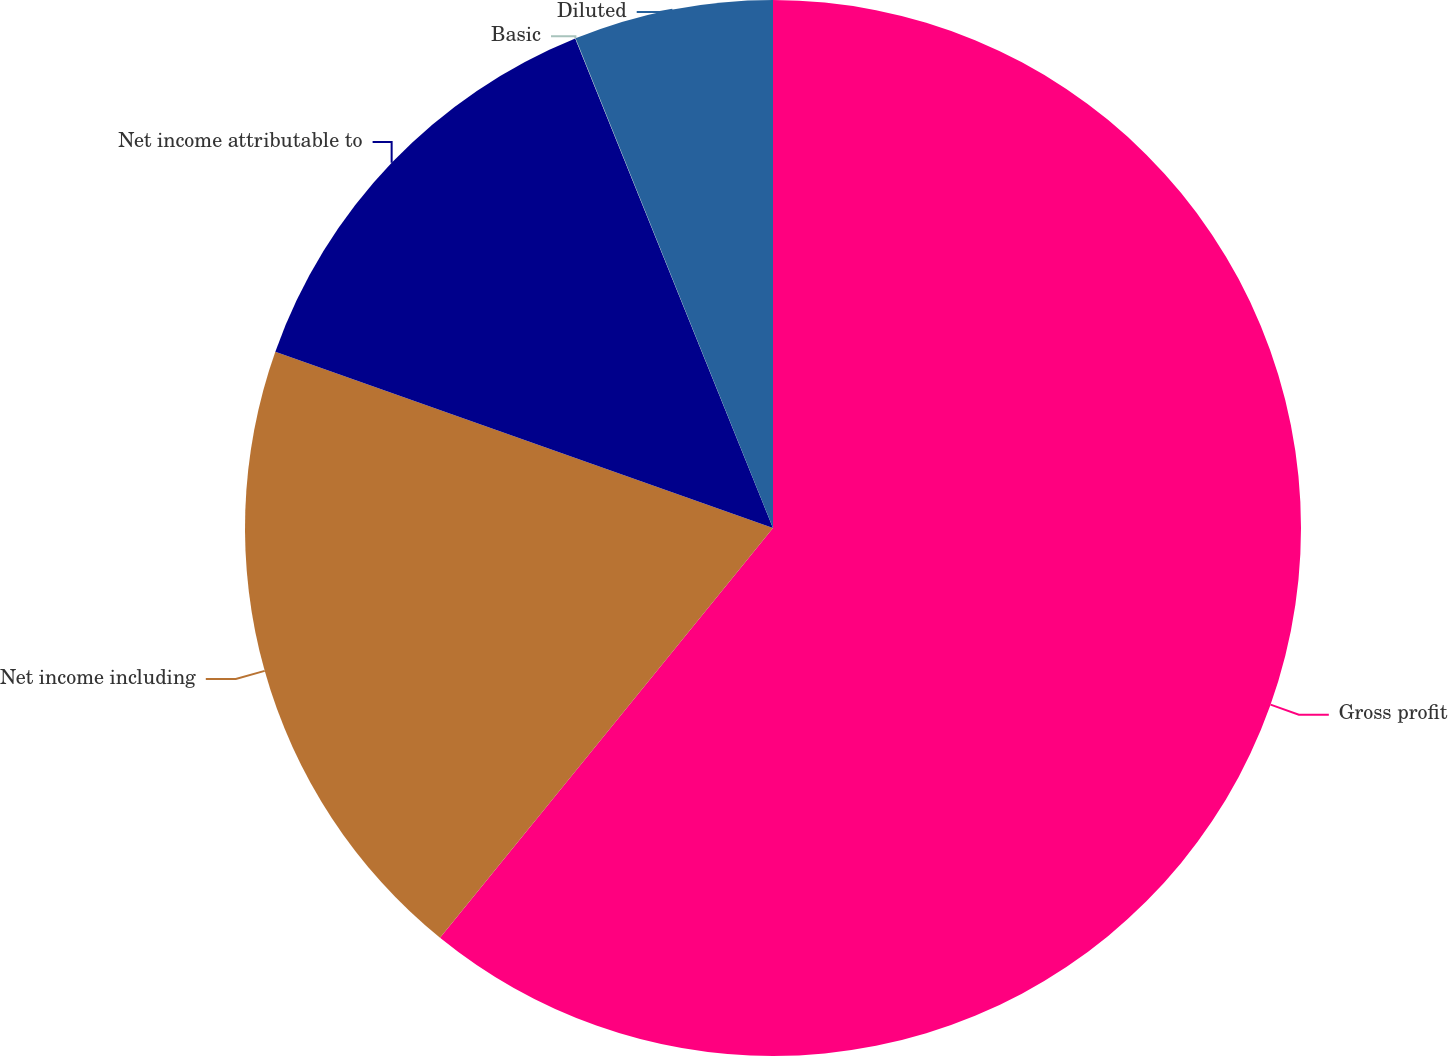Convert chart to OTSL. <chart><loc_0><loc_0><loc_500><loc_500><pie_chart><fcel>Gross profit<fcel>Net income including<fcel>Net income attributable to<fcel>Basic<fcel>Diluted<nl><fcel>60.86%<fcel>19.56%<fcel>13.47%<fcel>0.01%<fcel>6.1%<nl></chart> 